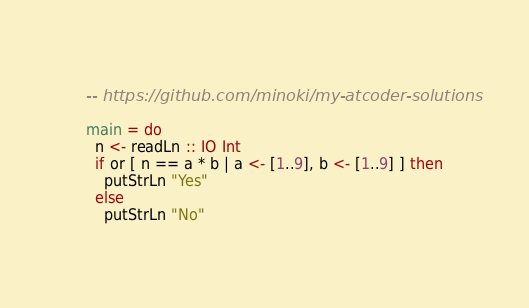Convert code to text. <code><loc_0><loc_0><loc_500><loc_500><_Haskell_>-- https://github.com/minoki/my-atcoder-solutions

main = do
  n <- readLn :: IO Int
  if or [ n == a * b | a <- [1..9], b <- [1..9] ] then
    putStrLn "Yes"
  else
    putStrLn "No"
</code> 